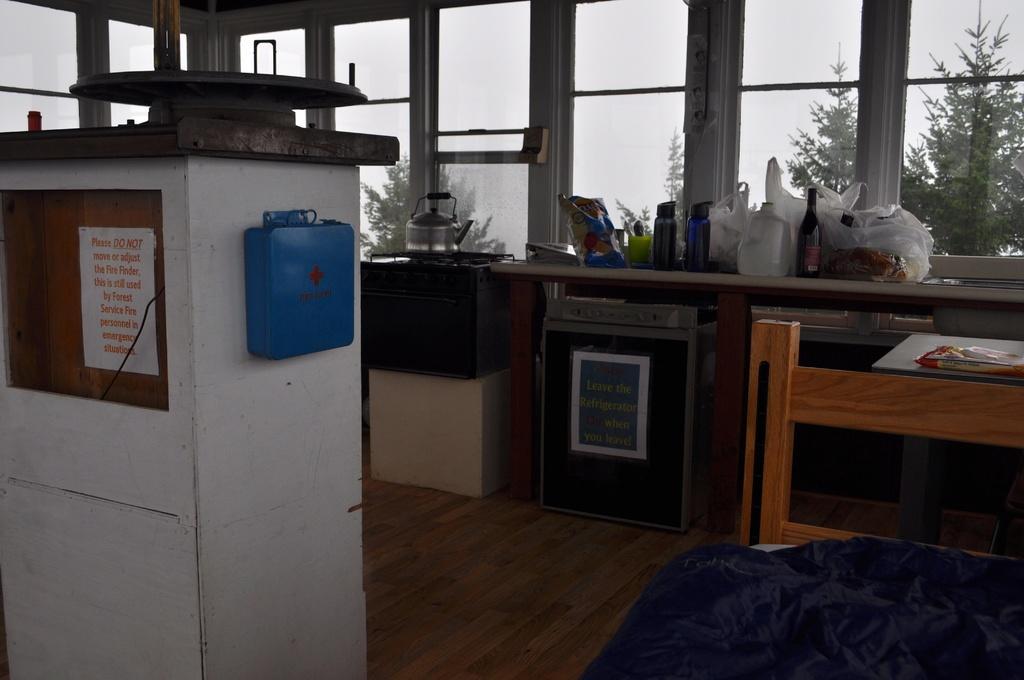In one or two sentences, can you explain what this image depicts? In this picture I can see a kettle on the stove, there are bottles, bags and some other objects on the cabinet, there is a dish washer, there is a first aid box, there is a chair and there are some other objects, there are windows and in the background there are trees. 